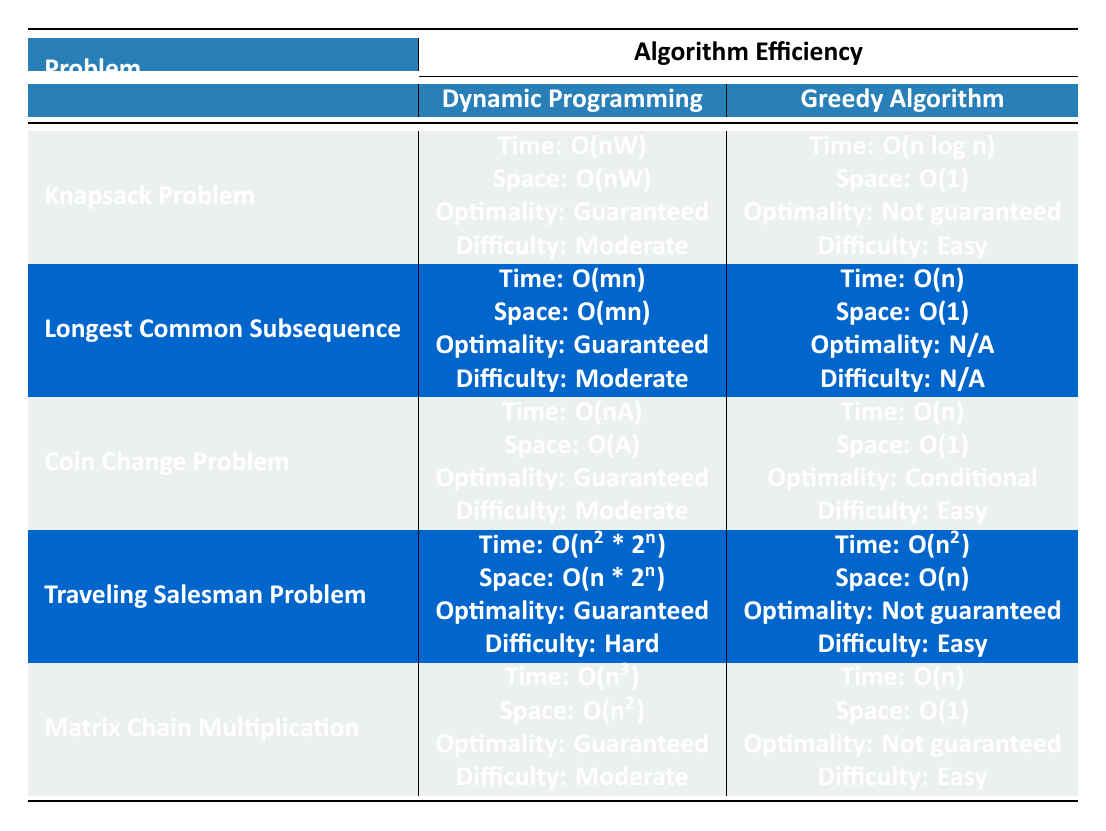What is the time complexity for the Greedy Algorithm in the Coin Change Problem? The table lists the time complexity for the Greedy Algorithm in the Coin Change Problem as O(n). This can be directly found under the "Greedy Algorithm" column for the "Coin Change Problem" row.
Answer: O(n) Is the Greedy Algorithm optimal for the Traveling Salesman Problem? Referring to the table, under the "Greedy Algorithm" column for the "Traveling Salesman Problem," it states that the optimality is "Not guaranteed." Thus, the Greedy Algorithm is not optimal for this problem.
Answer: No What is the space complexity difference between the Dynamic Programming and Greedy Algorithm in the Knapsack Problem? The space complexity for the Dynamic Programming in the Knapsack Problem is O(nW), while for the Greedy Algorithm, it is O(1). The difference would be calculated as O(nW) - O(1), which emphasizes that Dynamic Programming requires significantly more space.
Answer: O(nW) - O(1) In which problem does the Greedy Algorithm have the best time complexity? Let's look at the time complexities under the Greedy Algorithm across the problems: O(n log n) for Knapsack, O(n) for Longest Common Subsequence, O(n) for Coin Change, O(n^2) for Traveling Salesman, and O(n) for Matrix Chain Multiplication. Coin Change, Longest Common Subsequence, and Matrix Chain Multiplication all have the same best time complexity of O(n).
Answer: Coin Change, Longest Common Subsequence, Matrix Chain Multiplication True or False: The Dynamic Programming approach for Matrix Chain Multiplication has a guaranteed optimal solution. The table indicates that for Matrix Chain Multiplication, the Dynamic Programming approach guarantees an optimal solution, verifying that the statement holds true.
Answer: True What is the implementation difficulty of the Dynamic Programming approach for the Longest Common Subsequence? According to the table, the implementation difficulty for the Dynamic Programming approach in the Longest Common Subsequence is classified as "Moderate." This information is found in the corresponding row in the Dynamic Programming column.
Answer: Moderate 